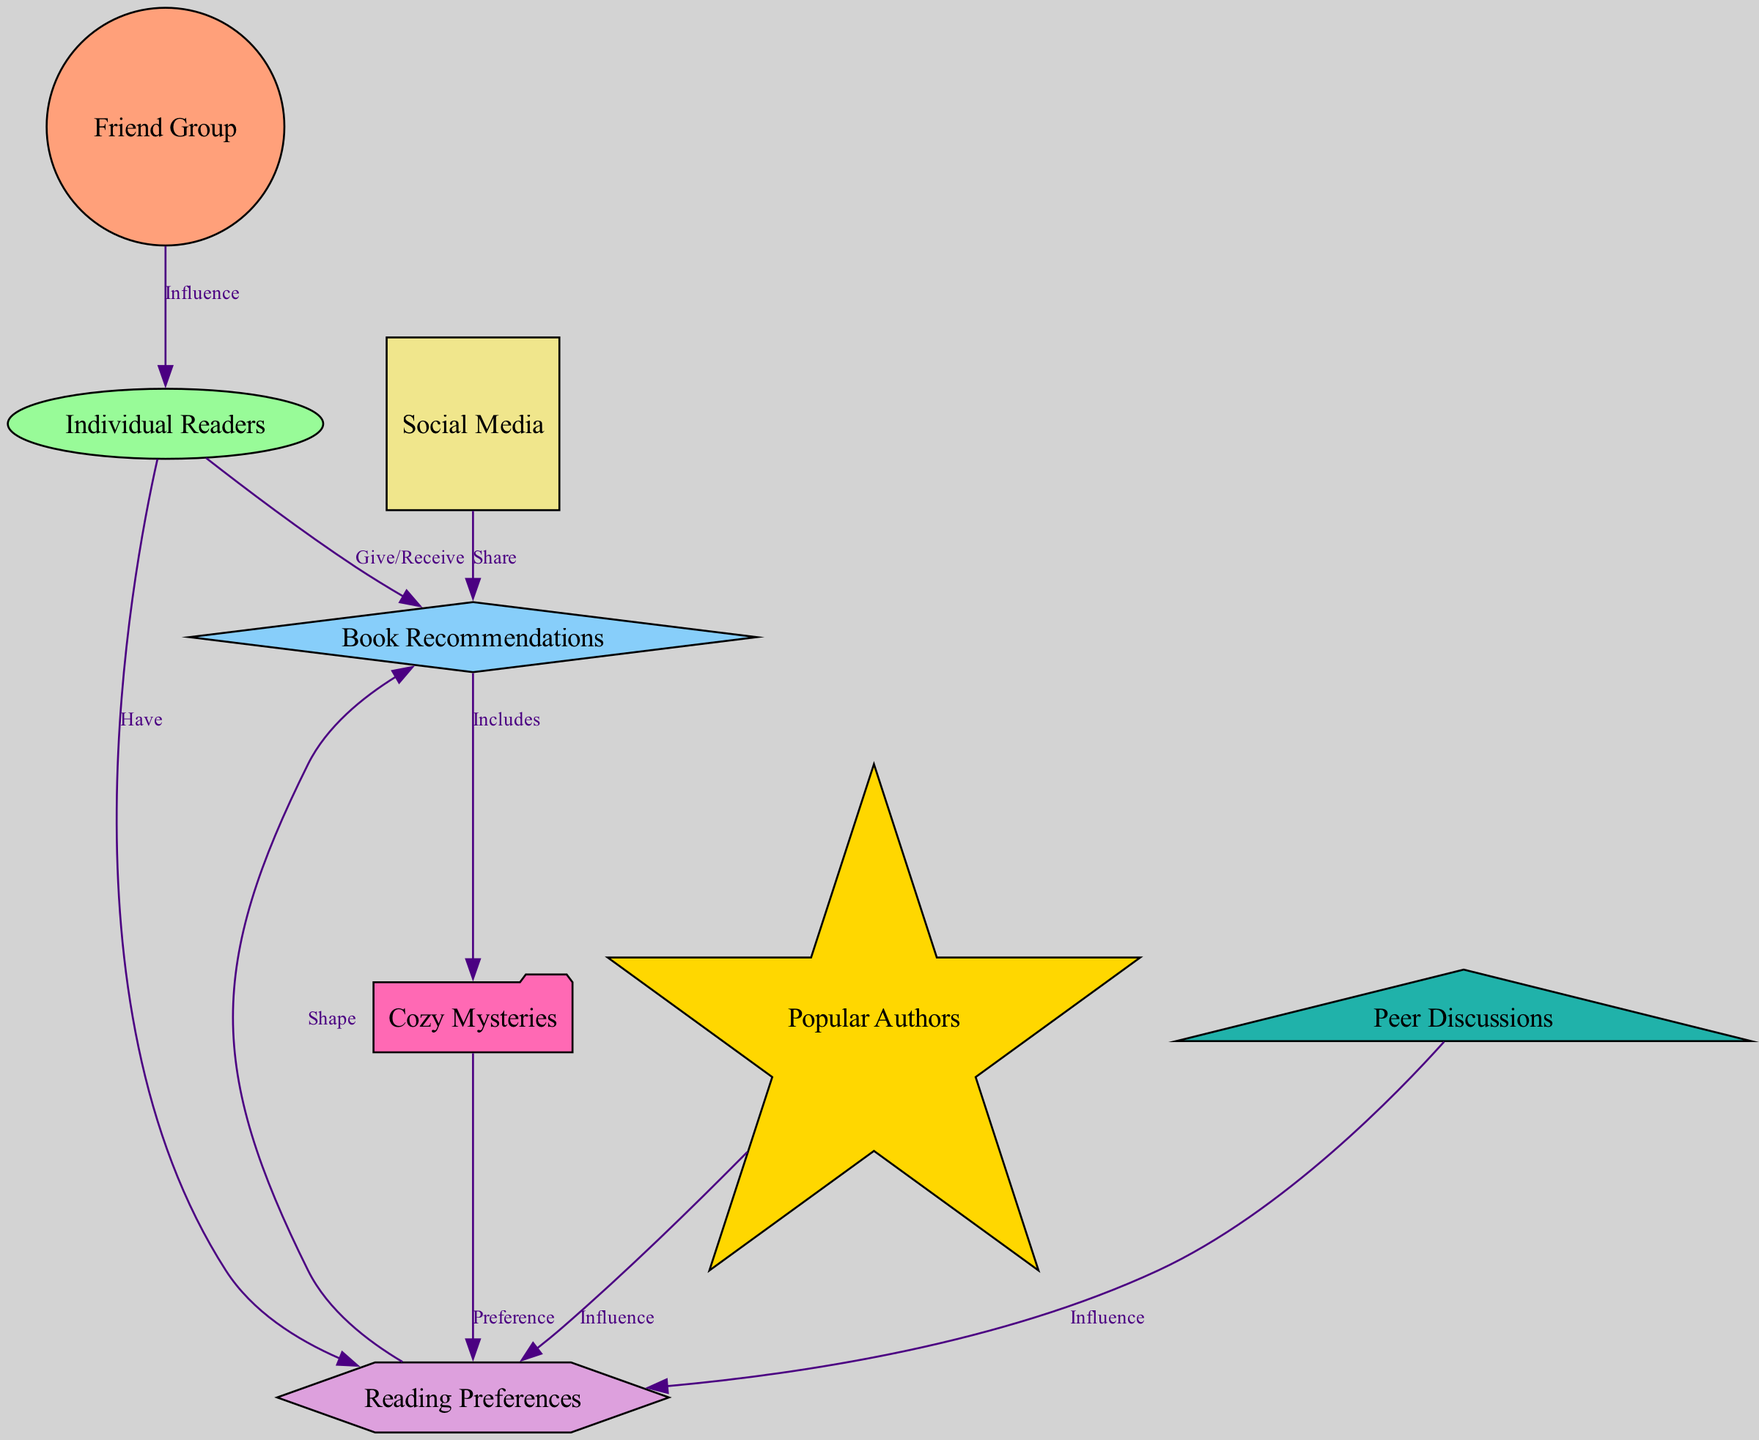What is the total number of nodes in the diagram? The diagram has eight nodes represented, which include Friend Group, Individual Readers, Book Recommendations, Reading Preferences, Social Media, Popular Authors, Cozy Mysteries, and Peer Discussions.
Answer: 8 How do Individual Readers influence Book Recommendations? The edge connecting Individual Readers to Book Recommendations is labeled "Give/Receive," indicating that Individual Readers actively participate in giving and receiving book recommendations.
Answer: Give/Receive Which node represents the type of books that includes Cozy Mysteries? The edge between Book Recommendations and Cozy Mysteries is labeled "Includes," showing that Book Recommendations specifically include Cozy Mysteries as part of the reading choices.
Answer: Book Recommendations What influences Reading Preferences according to the diagram? Reading Preferences are influenced by Peer Discussions and Popular Authors as indicated by the edges labeled "Influence" connecting these nodes to Reading Preferences.
Answer: Peer Discussions, Popular Authors How many connections lead into the Individual Readers node? The Individual Readers node has three incoming edges: one from Friend Group labeled "Influence," one from Book Recommendations labeled "Give/Receive," and one from Reading Preferences labeled "Have." Therefore, it has three connections.
Answer: 3 What type of node is Cozy Mysteries in the diagram? Cozy Mysteries is represented as a folder-shaped node, signifying that it refers specifically to a genre or type of book.
Answer: Folder What do Peer Discussions influence directly? Peer Discussions directly influence Reading Preferences, as indicated by the edge labeled "Influence" pointing from Peer Discussions to Reading Preferences.
Answer: Reading Preferences Which node shares book recommendations through social media? The edge between Social Media and Book Recommendations is labeled "Share," indicating that Social Media acts as a medium for sharing book recommendations among peers.
Answer: Book Recommendations What is the relationship between Reading Preferences and Book Recommendations? The edge connecting Reading Preferences to Book Recommendations is labeled "Shape," implying that Reading Preferences shape or define the nature of the book recommendations that are shared.
Answer: Shape 